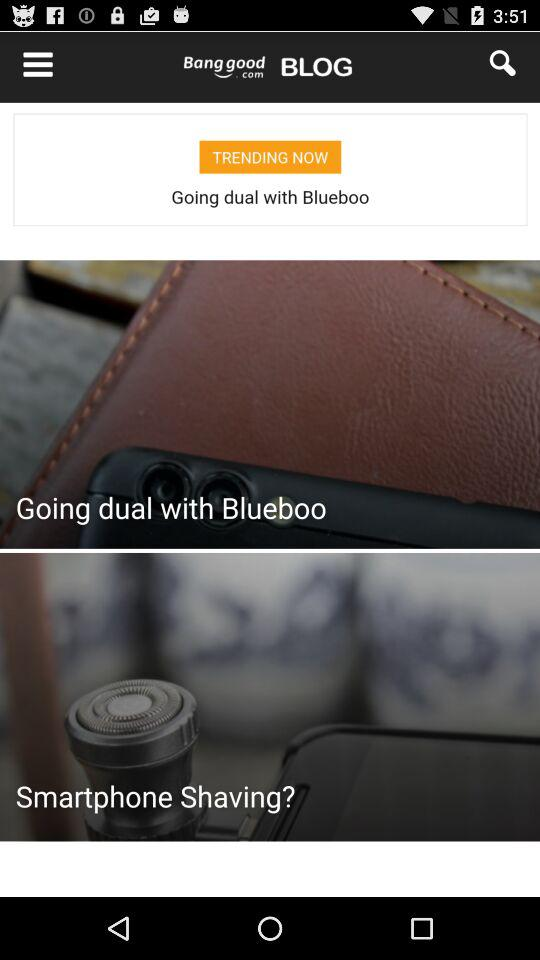What are the sharing options? The sharing options are "Facebook", "WhatsApp" and "Email". 